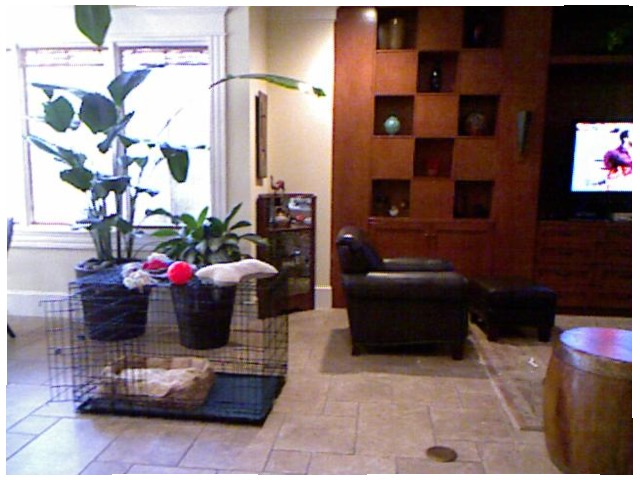<image>
Is there a cage to the left of the chair? Yes. From this viewpoint, the cage is positioned to the left side relative to the chair. Is there a dog bed to the left of the kennel? No. The dog bed is not to the left of the kennel. From this viewpoint, they have a different horizontal relationship. Is there a bed in the kennel? Yes. The bed is contained within or inside the kennel, showing a containment relationship. 